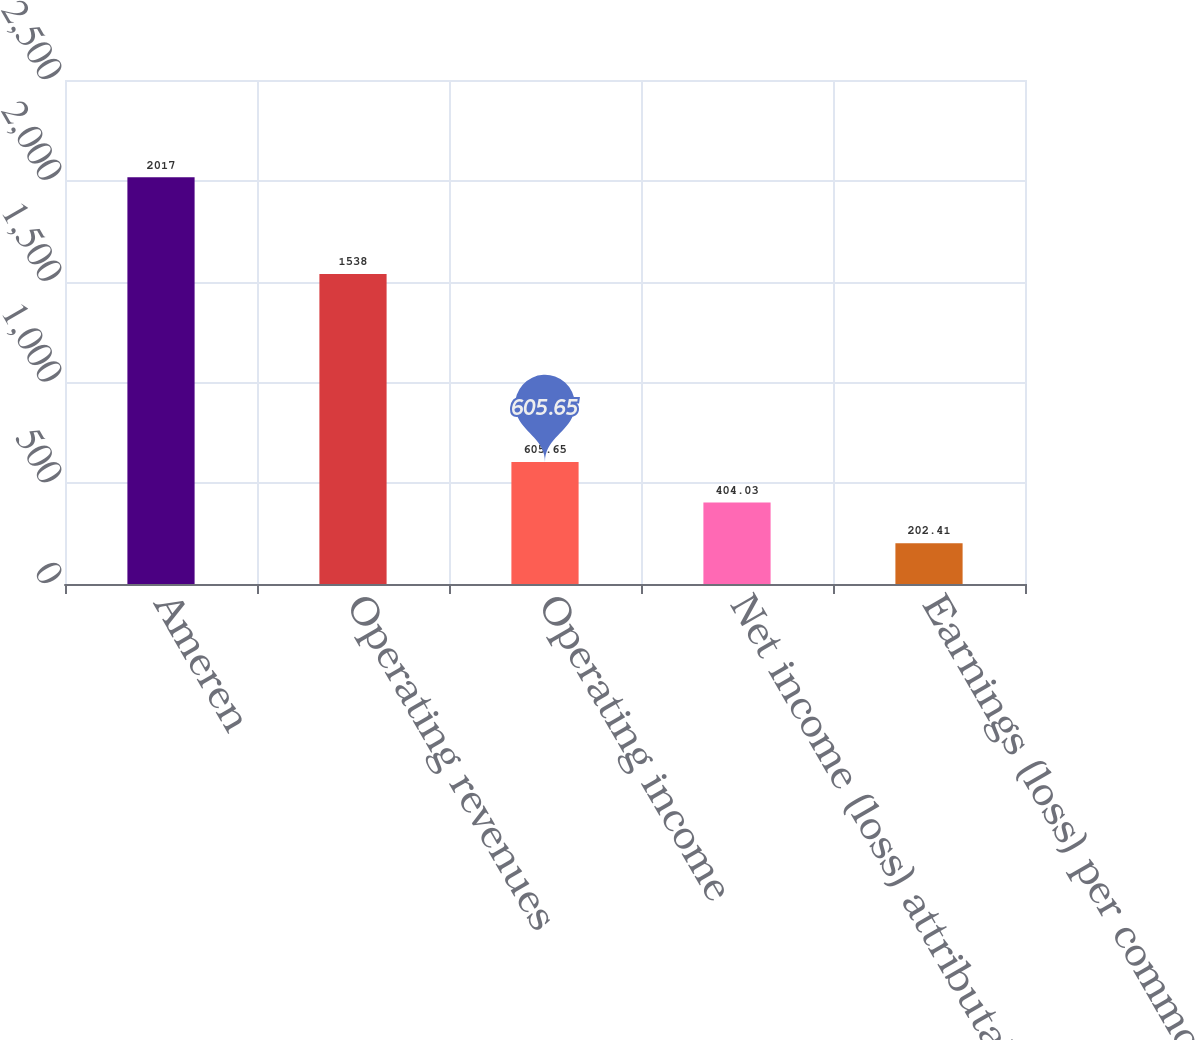<chart> <loc_0><loc_0><loc_500><loc_500><bar_chart><fcel>Ameren<fcel>Operating revenues<fcel>Operating income<fcel>Net income (loss) attributable<fcel>Earnings (loss) per common<nl><fcel>2017<fcel>1538<fcel>605.65<fcel>404.03<fcel>202.41<nl></chart> 